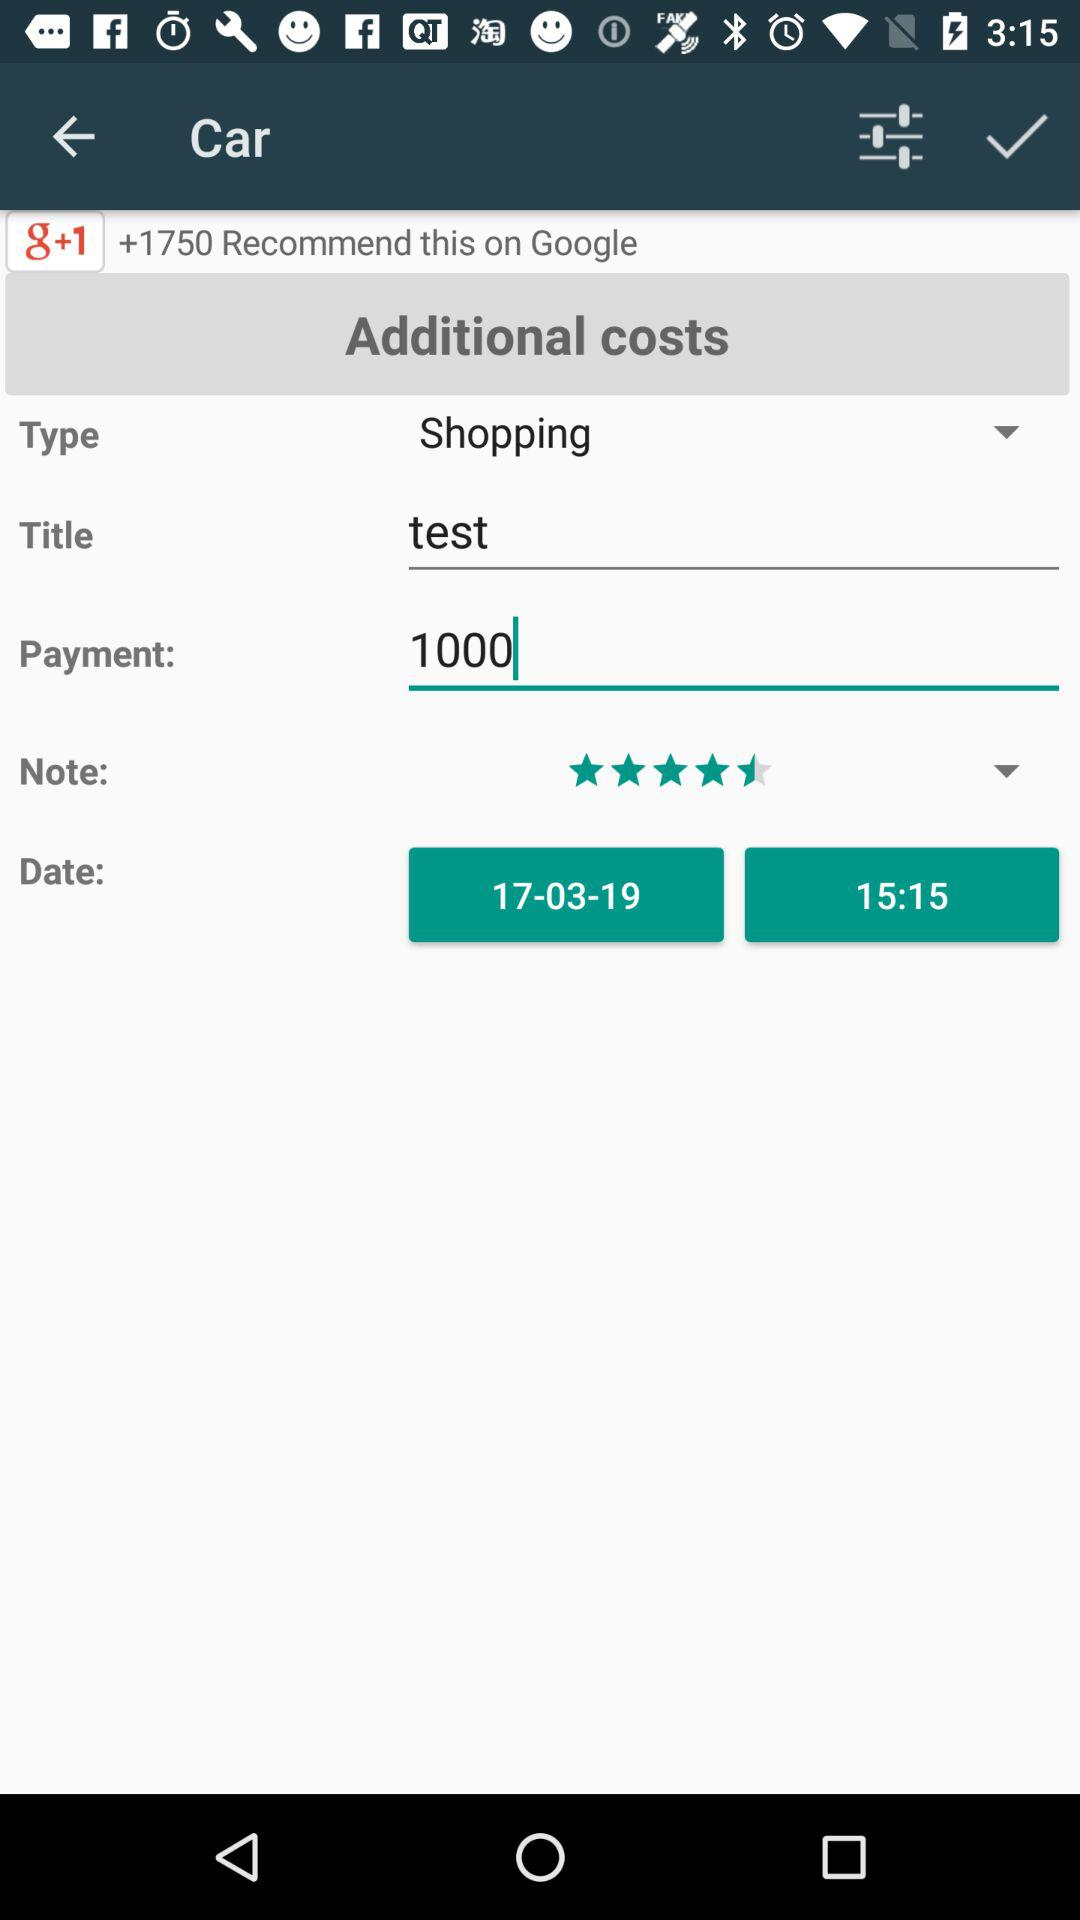What is the title? The title is "test". 